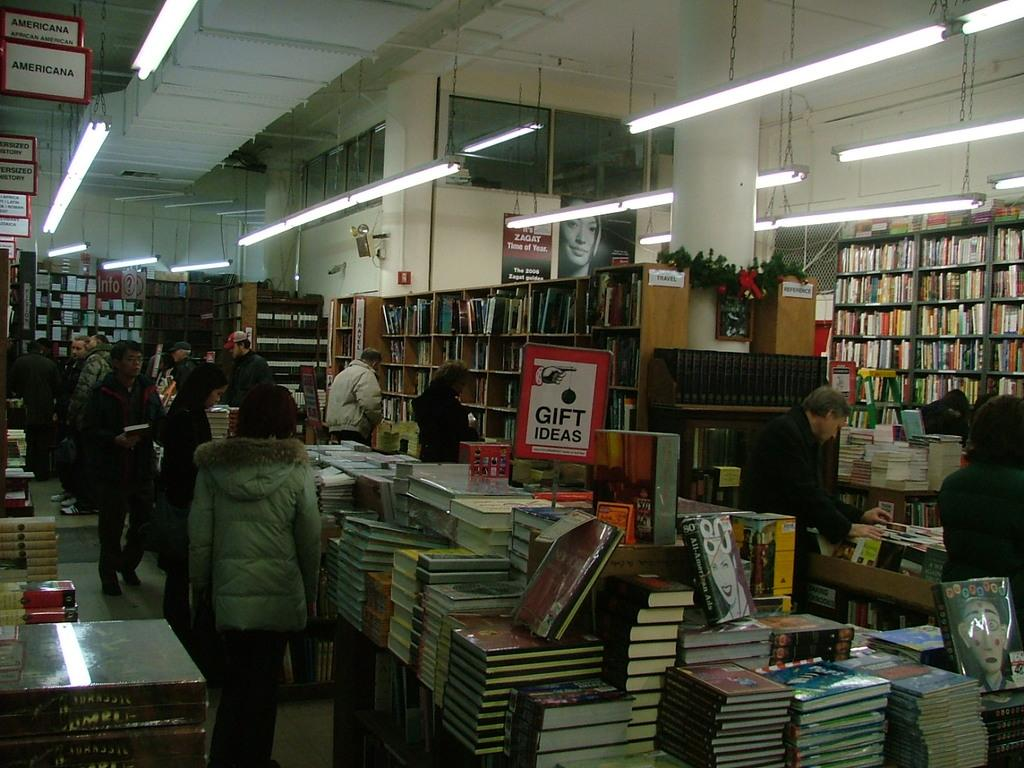<image>
Offer a succinct explanation of the picture presented. In a dimly it bookstore a stack of books sits on a table labeled gift ideas. 